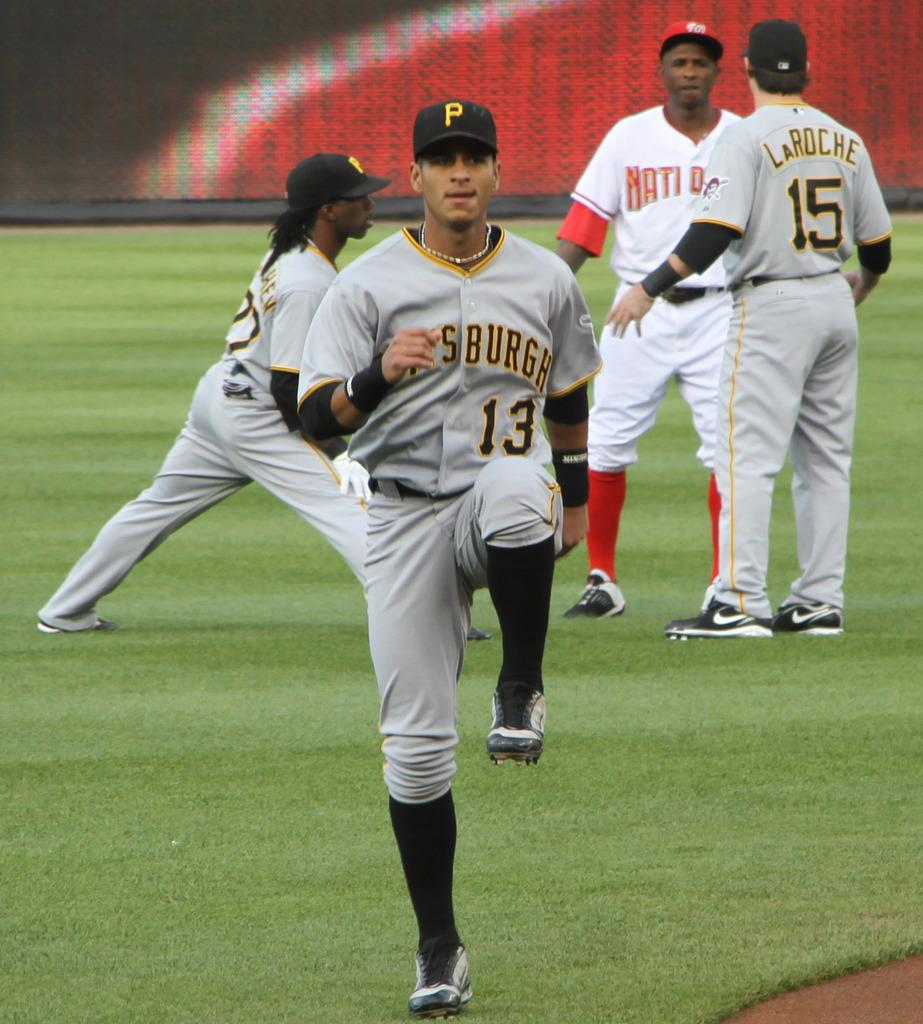<image>
Provide a brief description of the given image. Two Pittsburgh Pirates baseball players stretch and warm up while another of their players talks to someone from the other team out in the field. 